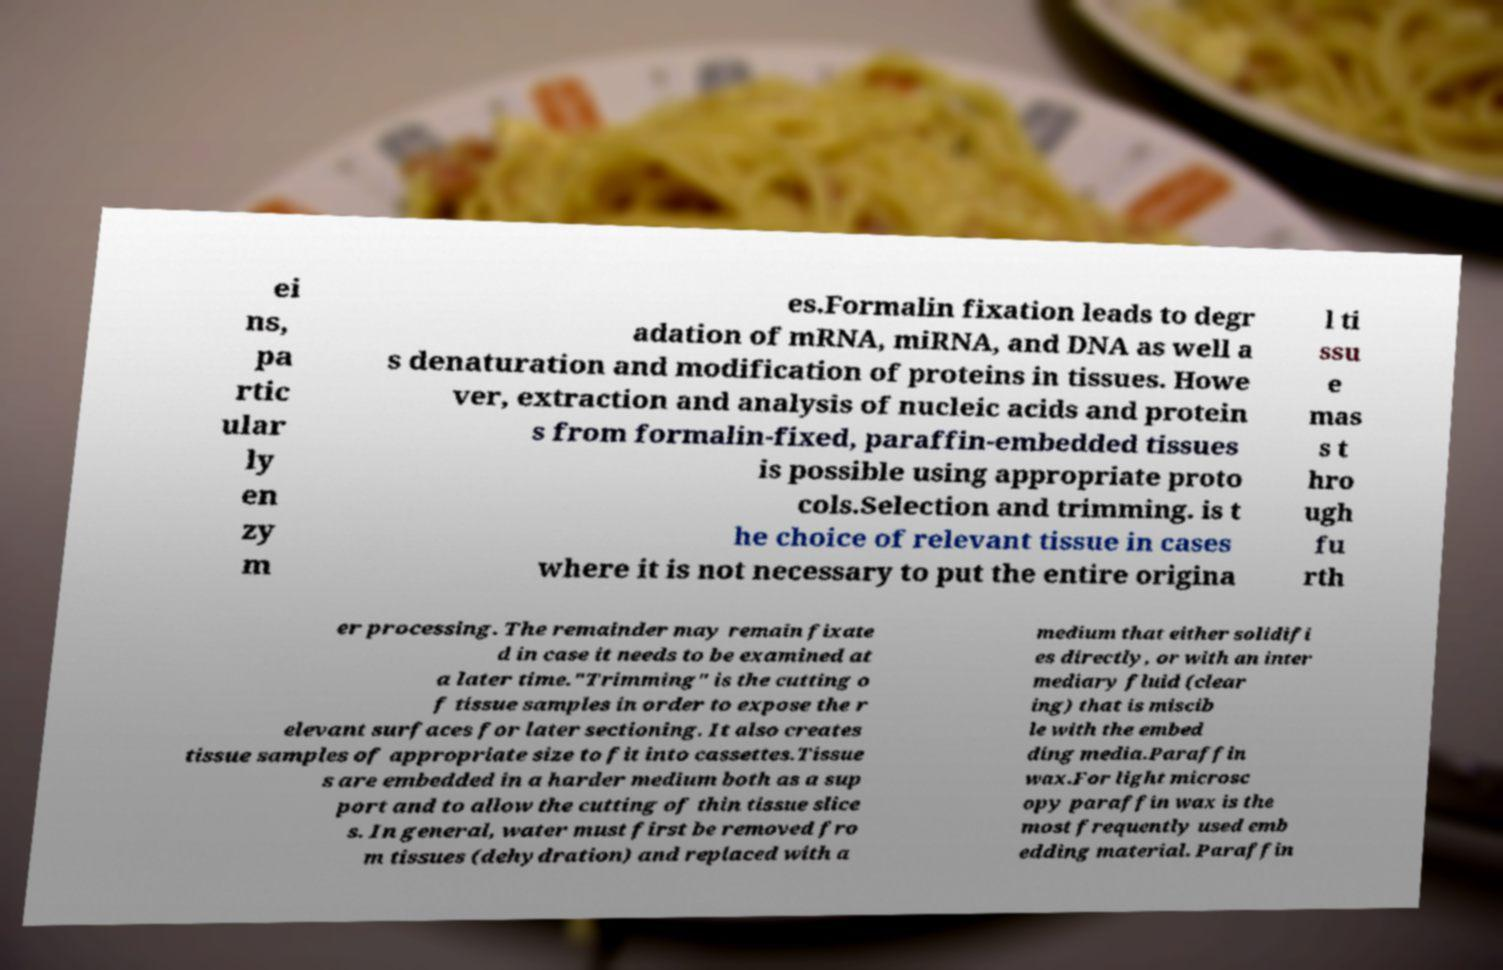Please read and relay the text visible in this image. What does it say? ei ns, pa rtic ular ly en zy m es.Formalin fixation leads to degr adation of mRNA, miRNA, and DNA as well a s denaturation and modification of proteins in tissues. Howe ver, extraction and analysis of nucleic acids and protein s from formalin-fixed, paraffin-embedded tissues is possible using appropriate proto cols.Selection and trimming. is t he choice of relevant tissue in cases where it is not necessary to put the entire origina l ti ssu e mas s t hro ugh fu rth er processing. The remainder may remain fixate d in case it needs to be examined at a later time."Trimming" is the cutting o f tissue samples in order to expose the r elevant surfaces for later sectioning. It also creates tissue samples of appropriate size to fit into cassettes.Tissue s are embedded in a harder medium both as a sup port and to allow the cutting of thin tissue slice s. In general, water must first be removed fro m tissues (dehydration) and replaced with a medium that either solidifi es directly, or with an inter mediary fluid (clear ing) that is miscib le with the embed ding media.Paraffin wax.For light microsc opy paraffin wax is the most frequently used emb edding material. Paraffin 